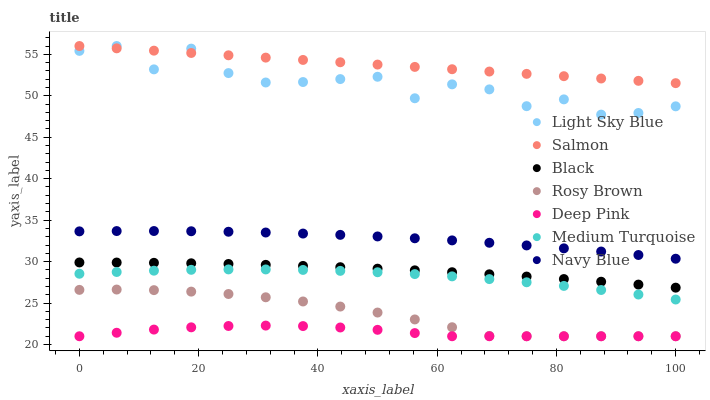Does Deep Pink have the minimum area under the curve?
Answer yes or no. Yes. Does Salmon have the maximum area under the curve?
Answer yes or no. Yes. Does Navy Blue have the minimum area under the curve?
Answer yes or no. No. Does Navy Blue have the maximum area under the curve?
Answer yes or no. No. Is Salmon the smoothest?
Answer yes or no. Yes. Is Light Sky Blue the roughest?
Answer yes or no. Yes. Is Navy Blue the smoothest?
Answer yes or no. No. Is Navy Blue the roughest?
Answer yes or no. No. Does Deep Pink have the lowest value?
Answer yes or no. Yes. Does Navy Blue have the lowest value?
Answer yes or no. No. Does Light Sky Blue have the highest value?
Answer yes or no. Yes. Does Navy Blue have the highest value?
Answer yes or no. No. Is Medium Turquoise less than Navy Blue?
Answer yes or no. Yes. Is Light Sky Blue greater than Navy Blue?
Answer yes or no. Yes. Does Deep Pink intersect Rosy Brown?
Answer yes or no. Yes. Is Deep Pink less than Rosy Brown?
Answer yes or no. No. Is Deep Pink greater than Rosy Brown?
Answer yes or no. No. Does Medium Turquoise intersect Navy Blue?
Answer yes or no. No. 